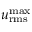Convert formula to latex. <formula><loc_0><loc_0><loc_500><loc_500>u _ { r m s } ^ { \max }</formula> 